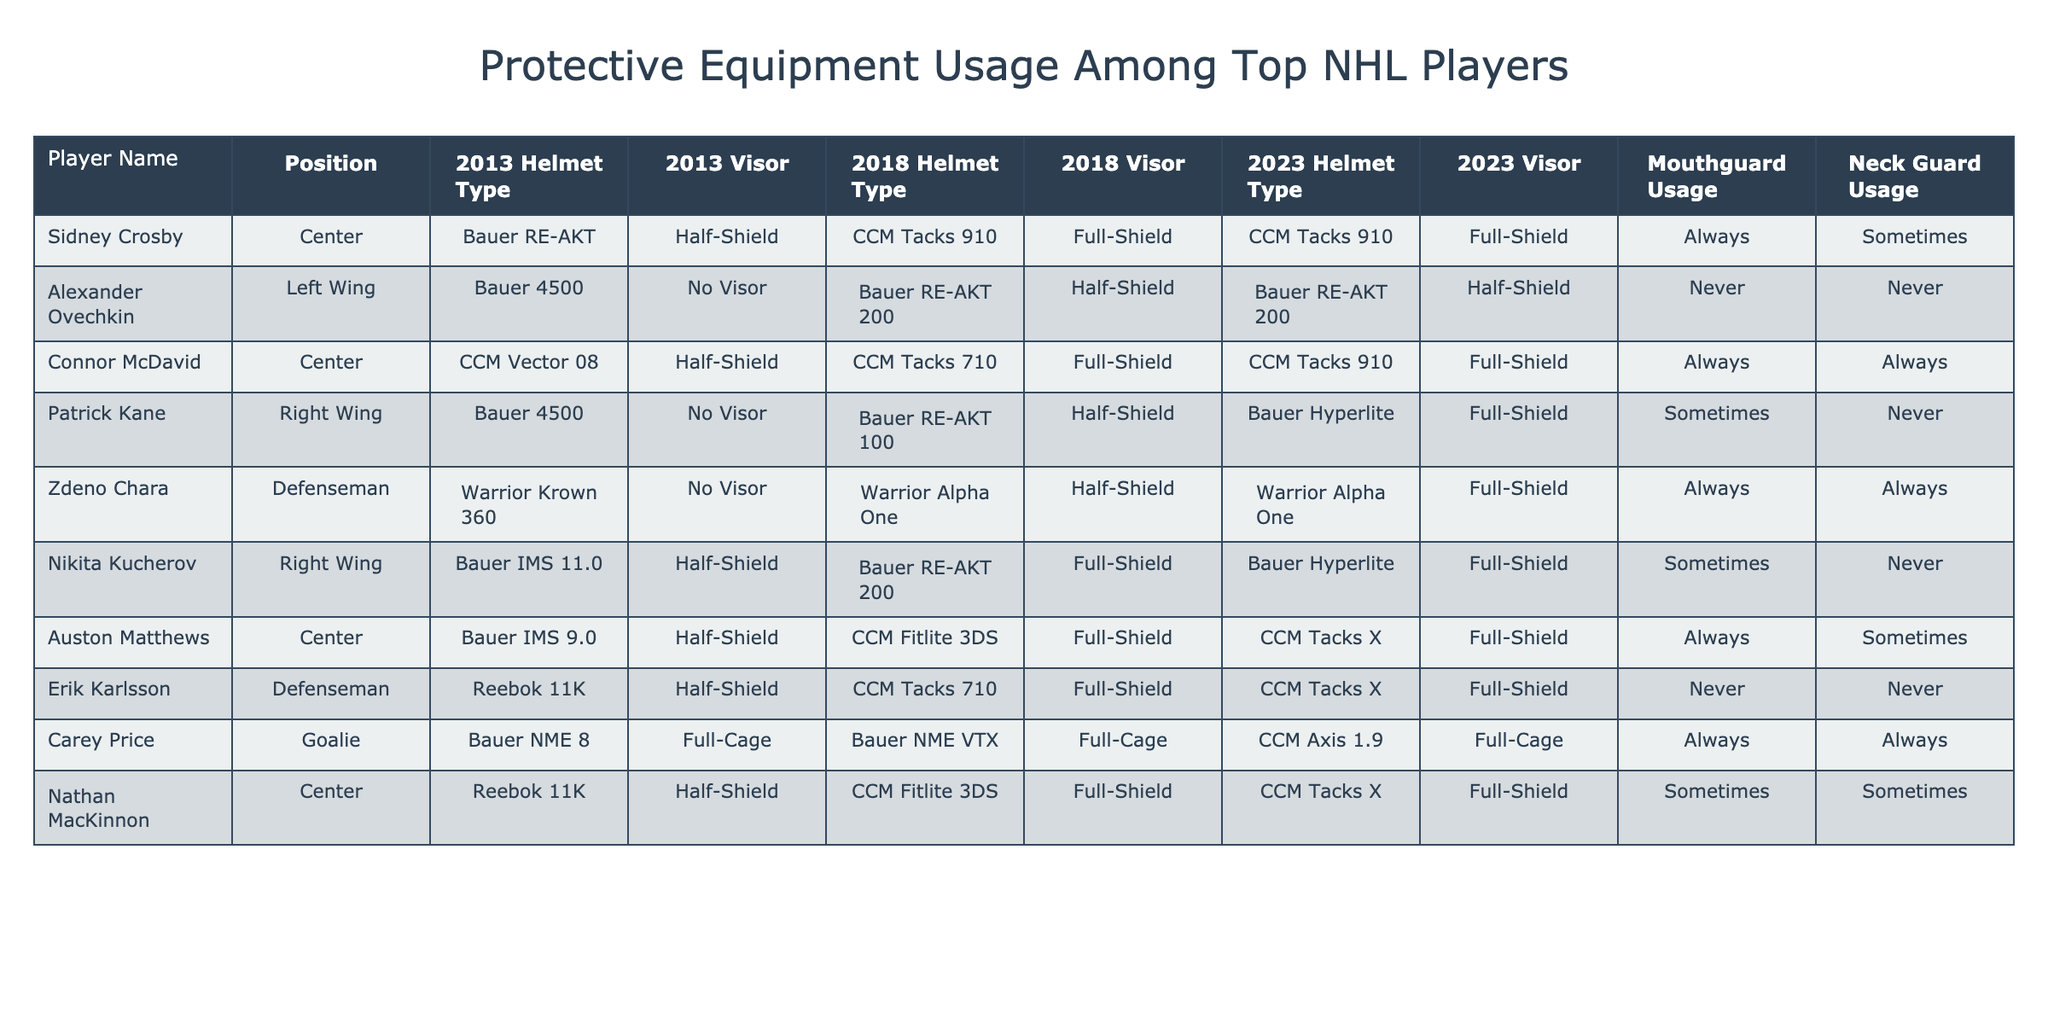What helmet type did Sidney Crosby use in 2013? The table shows that Sidney Crosby used the Bauer RE-AKT helmet type in 2013.
Answer: Bauer RE-AKT Which players consistently used a full-shield visor in 2023? Looking at the data for 2023, Sidney Crosby, Connor McDavid, Zdeno Chara, Auston Matthews, and Carey Price all used a full-shield visor consistently.
Answer: 5 players Did Alexander Ovechkin use a visor in any of the years? According to the table, Alexander Ovechkin did not use a visor in 2013 and continued with a half-shield in 2018 and 2023, so he only used a visor type in those years.
Answer: Yes How many players used a mouthguard "Always" in 2023? The table indicates that Sidney Crosby, Connor McDavid, Zdeno Chara, and Carey Price used a mouthguard "Always" in 2023. This totals four players.
Answer: 4 players Which player increased their neck guard usage from 2013 to 2023? For neck guard usage, the only player who went from "Sometimes" in 2013 to "Always" in 2023 is Zdeno Chara.
Answer: Zdeno Chara What percentage of players used a half-shield in 2018? In 2018, the players who used a half-shield visor are Sidney Crosby, Patrick Kane, Nikita Kucherov, and Nathan MacKinnon. There are 8 players total, so (4/8)*100 = 50%.
Answer: 50% Who has the most consistent use of protective equipment over the years? Connor McDavid used the same helmet type and visor type (full-shield) across all three years (2013, 2018, 2023), showing the most consistency.
Answer: Connor McDavid Is there a difference in helmet type usage among centers from 2013 to 2023? Comparing helmet types for centers: Sidney Crosby changed from Bauer RE-AKT in 2013 to CCM Tacks 910 in 2023, while Connor McDavid upgraded from CCM Vector 08 to CCM Tacks 910. Therefore, both centers changed their helmet types.
Answer: Yes Who used the same helmet type in 2023 that they did in 2013? The table indicates that Zdeno Chara used the same Warrior helmet type in 2013 (Warrior Krown 360) and maintained Warrior Alpha One until 2023, but it’s not the same model, so no player maintained the exact type.
Answer: No players Which player had the most upgrades in helmet types from 2013 to 2023? The player with the most upgrades is Patrick Kane, changing his helmet type from Bauer 4500 in 2013 to Bauer Hyperlite in 2023, a total of two changes.
Answer: Patrick Kane 